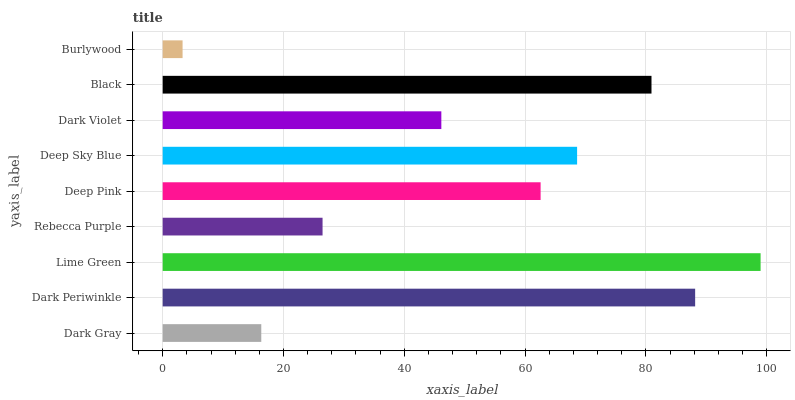Is Burlywood the minimum?
Answer yes or no. Yes. Is Lime Green the maximum?
Answer yes or no. Yes. Is Dark Periwinkle the minimum?
Answer yes or no. No. Is Dark Periwinkle the maximum?
Answer yes or no. No. Is Dark Periwinkle greater than Dark Gray?
Answer yes or no. Yes. Is Dark Gray less than Dark Periwinkle?
Answer yes or no. Yes. Is Dark Gray greater than Dark Periwinkle?
Answer yes or no. No. Is Dark Periwinkle less than Dark Gray?
Answer yes or no. No. Is Deep Pink the high median?
Answer yes or no. Yes. Is Deep Pink the low median?
Answer yes or no. Yes. Is Rebecca Purple the high median?
Answer yes or no. No. Is Dark Violet the low median?
Answer yes or no. No. 